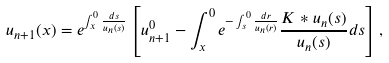<formula> <loc_0><loc_0><loc_500><loc_500>u _ { n + 1 } ( x ) = e ^ { \int ^ { 0 } _ { x } \frac { d s } { u _ { n } ( s ) } } \left [ u _ { n + 1 } ^ { 0 } - \int ^ { 0 } _ { x } e ^ { - \int ^ { 0 } _ { s } \frac { d r } { u _ { n } ( r ) } } \frac { K * u _ { n } ( s ) } { u _ { n } ( s ) } d s \right ] ,</formula> 